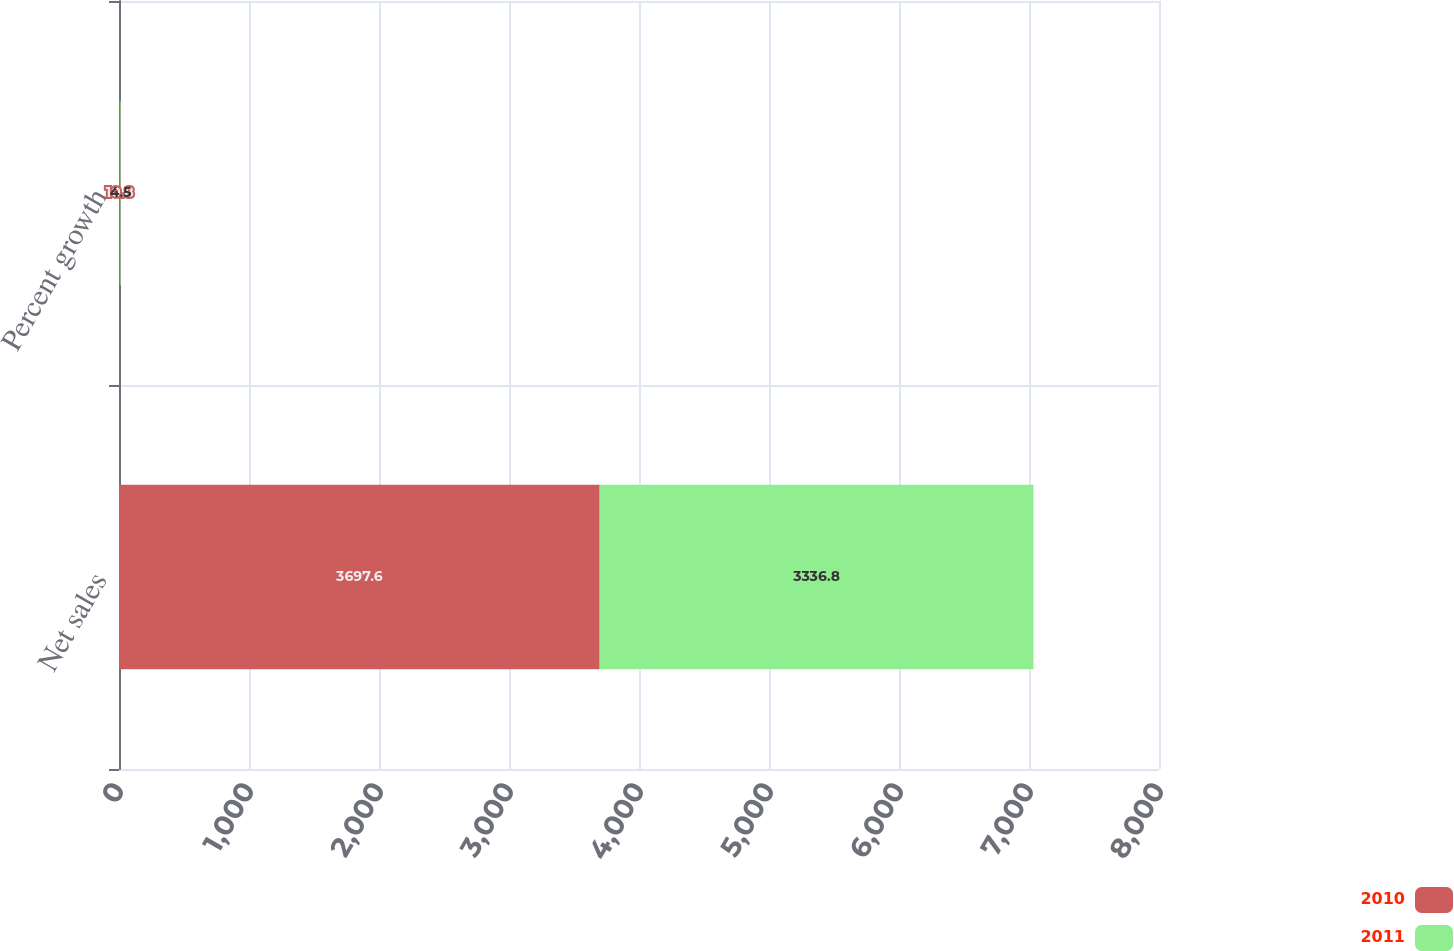Convert chart to OTSL. <chart><loc_0><loc_0><loc_500><loc_500><stacked_bar_chart><ecel><fcel>Net sales<fcel>Percent growth<nl><fcel>2010<fcel>3697.6<fcel>10.8<nl><fcel>2011<fcel>3336.8<fcel>4.5<nl></chart> 